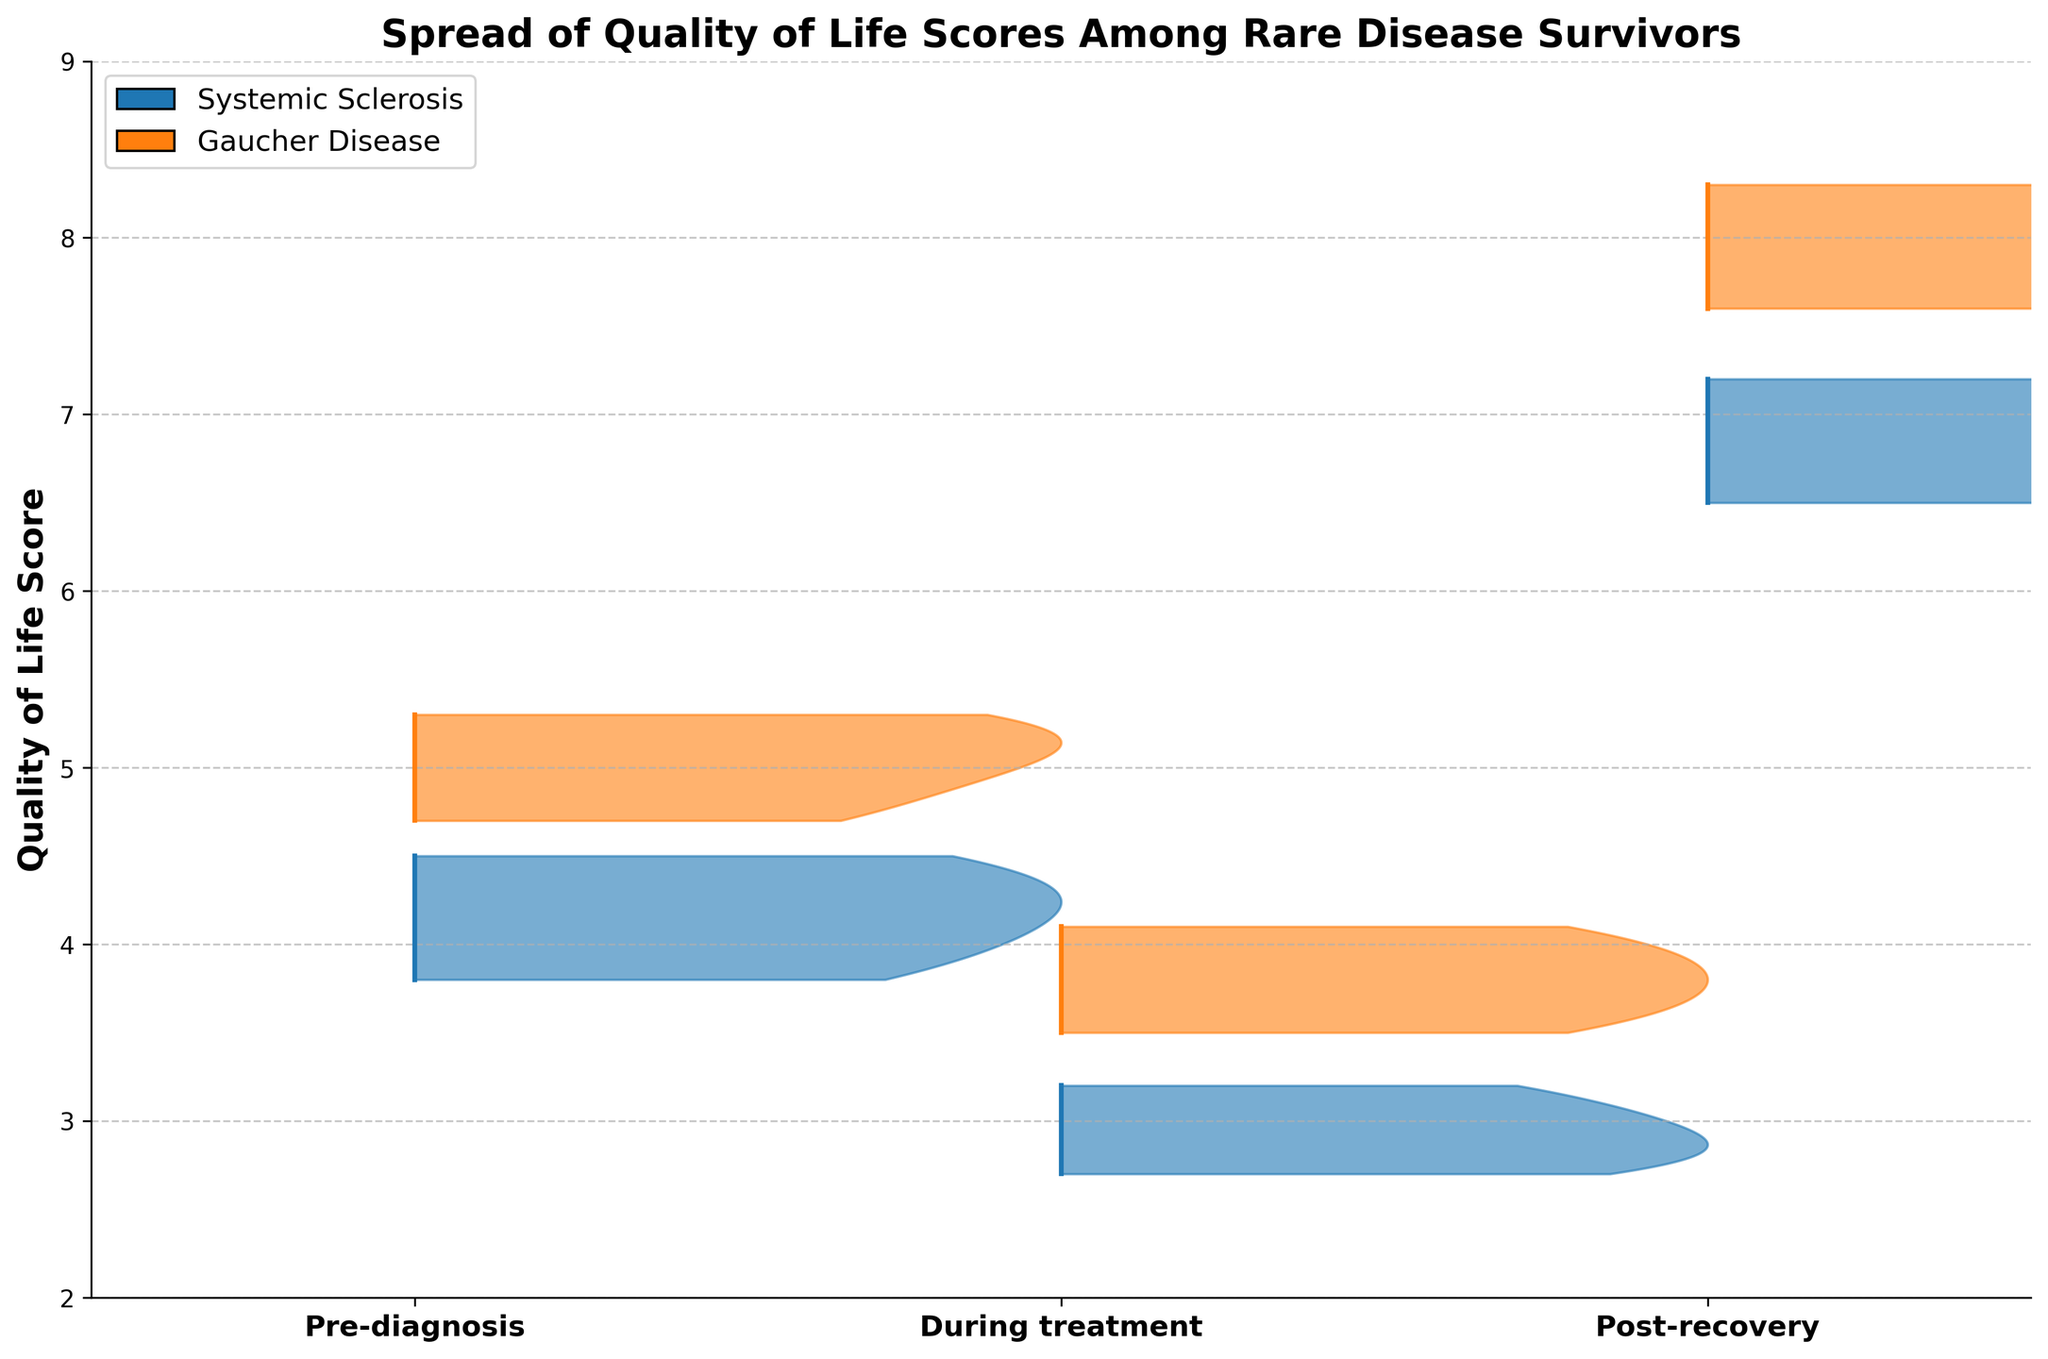What is the title of the plot? The title of the plot is displayed at the top and provides insight into the plot's primary purpose and content. It reads "Spread of Quality of Life Scores Among Rare Disease Survivors."
Answer: Spread of Quality of Life Scores Among Rare Disease Survivors What are the three phases compared in this plot? The x-axis of the plot lists three distinct phases for comparison: 'Pre-diagnosis,' 'During treatment,' and 'Post-recovery.'
Answer: Pre-diagnosis, During treatment, Post-recovery What is the range of the Quality of Life scores shown on the y-axis? The y-axis displays the Quality of Life scores, which range from 2 to 9, as indicated by the ticks.
Answer: 2 to 9 Which phase shows the lowest Quality of Life scores for Systemic Sclerosis? To find this, observe the lowest Quality of Life score for Systemic Sclerosis across the three phases. During treatment shows the lowest scores.
Answer: During treatment What is the general trend of Quality of Life scores for Gaucher Disease from Pre-diagnosis to Post-recovery? Look at the scores for Gaucher Disease across the three phases. Scores increase moving from Pre-diagnosis to During treatment to Post-recovery.
Answer: Increasing How do the highest Quality of Life scores during Post-recovery compare between Systemic Sclerosis and Gaucher Disease? Compare the highest y-value bars for Systemic Sclerosis and Gaucher Disease in the Post-recovery phase. Gaucher Disease scores go slightly higher than those for Systemic Sclerosis.
Answer: Gaucher Disease has higher scores What is the most noticeable difference in Quality of Life scores between Pre-diagnosis and During treatment for patients with Gaucher Disease? Observe the spread and general position of scores for Gaucher Disease between Pre-diagnosis and During treatment phases. Quality of Life scores decrease during treatment.
Answer: Scores decrease during treatment Which disease shows a wider spread of Quality of Life scores in the Post-recovery phase? Evaluate the width of the score ranges in the Post-recovery phase for both diseases. Systemic Sclerosis shows a wider spread in the scores.
Answer: Systemic Sclerosis How does the lowest Quality of Life score during treatment compare between Systemic Sclerosis and Gaucher Disease? Compare the minimum y-values during treatment for both diseases. The lowest Quality of Life score during treatment for Systemic Sclerosis is lower than that for Gaucher Disease.
Answer: Systemic Sclerosis is lower What does the plot primarily reveal about the impact of the treatment phase on patients' Quality of Life for both diseases? Analyze how Quality of Life scores change during the treatment phase for both diseases. Both diseases show a significant drop in scores during treatment, indicating a negative impact.
Answer: Significant drop in scores 